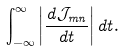<formula> <loc_0><loc_0><loc_500><loc_500>\int _ { - \infty } ^ { \infty } \left | \frac { d \mathcal { J } _ { m n } } { d t } \right | d t .</formula> 